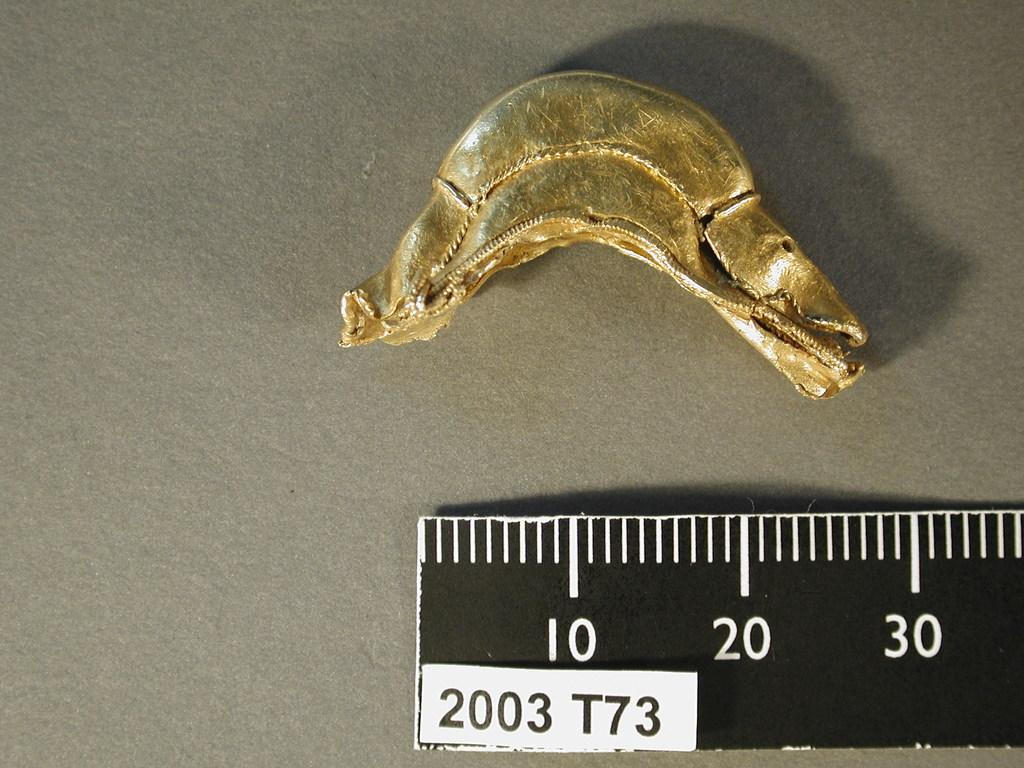<image>
Provide a brief description of the given image. A black ruler bears a sticker reading 2003 T73 on it. 